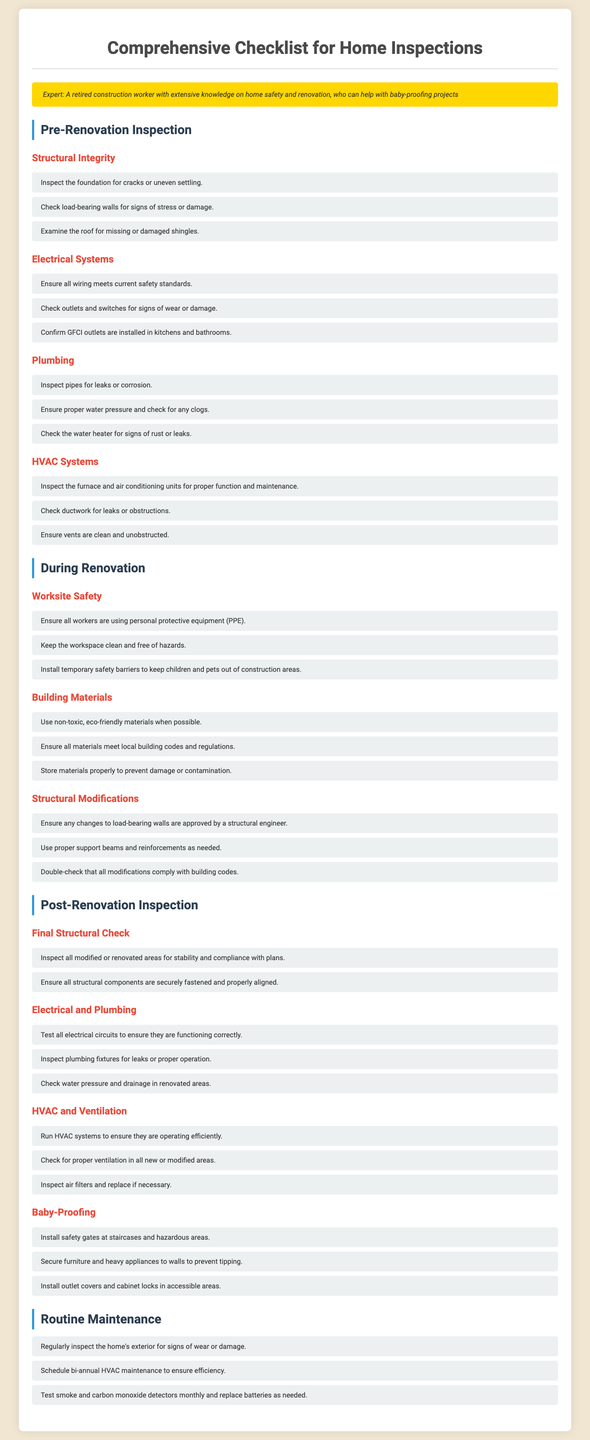What are the three areas inspected before renovations? The document lists Structural Integrity, Electrical Systems, and Plumbing as key areas to inspect before renovations.
Answer: Structural Integrity, Electrical Systems, Plumbing What should be checked for leaks in plumbing? The checklist specifies inspecting pipes and the water heater for leaks or corrosion.
Answer: Pipes and water heater How many recommendations are there for worksite safety during renovation? The checklist provides three specific recommendations under the Worksite Safety subsection.
Answer: Three What should be ensured when modifying load-bearing walls? The document states that any changes to load-bearing walls must be approved by a structural engineer.
Answer: Approved by a structural engineer What type of materials should be used when possible during renovations? The checklist suggests using non-toxic, eco-friendly materials when renovating.
Answer: Non-toxic, eco-friendly materials What is the first step in post-renovation inspection? The first step mentioned is to inspect all modified or renovated areas for stability and compliance with plans.
Answer: Inspect all modified or renovated areas for stability and compliance with plans How frequently should smoke and carbon monoxide detectors be tested? The document states that smoke and carbon monoxide detectors should be tested monthly.
Answer: Monthly How many baby-proofing measures are recommended post-renovation? The checklist lists three specific baby-proofing measures to implement after renovations.
Answer: Three What must be ensured regarding GFCI outlets? The document emphasizes confirming that GFCI outlets are installed in kitchens and bathrooms.
Answer: Installed in kitchens and bathrooms 